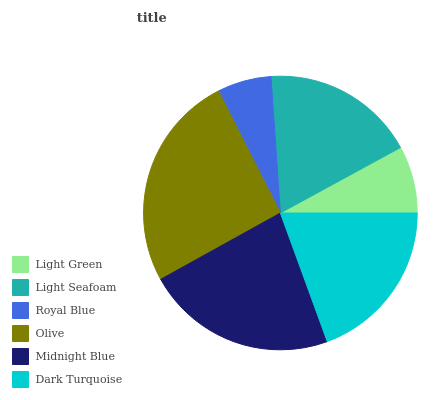Is Royal Blue the minimum?
Answer yes or no. Yes. Is Olive the maximum?
Answer yes or no. Yes. Is Light Seafoam the minimum?
Answer yes or no. No. Is Light Seafoam the maximum?
Answer yes or no. No. Is Light Seafoam greater than Light Green?
Answer yes or no. Yes. Is Light Green less than Light Seafoam?
Answer yes or no. Yes. Is Light Green greater than Light Seafoam?
Answer yes or no. No. Is Light Seafoam less than Light Green?
Answer yes or no. No. Is Dark Turquoise the high median?
Answer yes or no. Yes. Is Light Seafoam the low median?
Answer yes or no. Yes. Is Olive the high median?
Answer yes or no. No. Is Midnight Blue the low median?
Answer yes or no. No. 